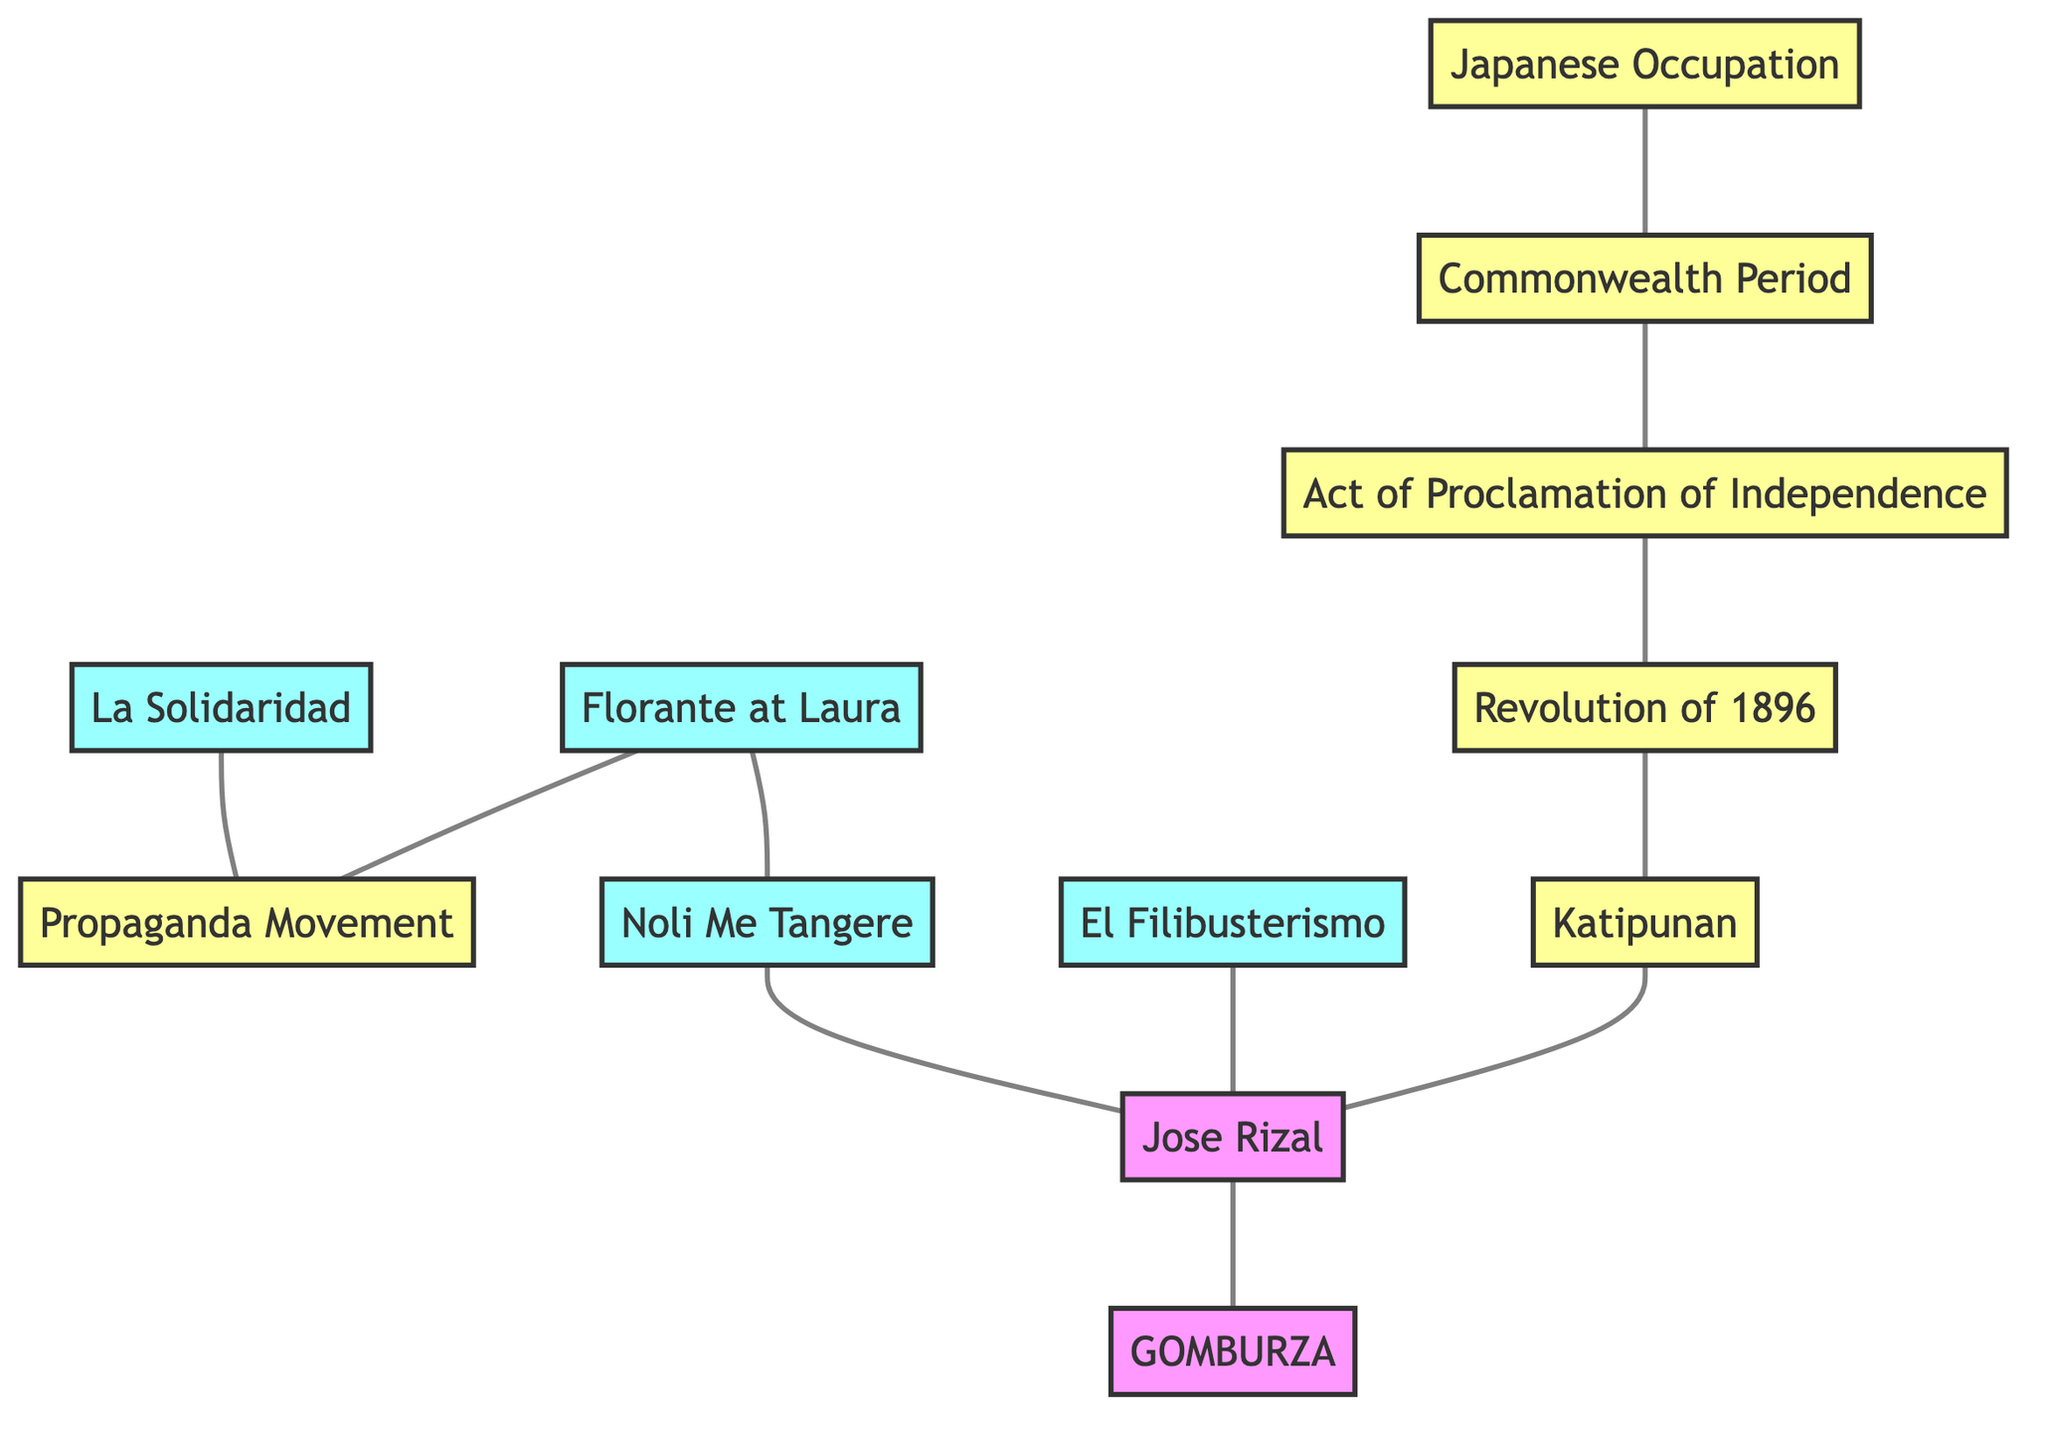What is the primary literary work associated with Jose Rizal? Jose Rizal is directly linked to two literary works in the diagram: "Noli Me Tangere" and "El Filibusterismo". The question specifically asks for one, so either of these is correct.
Answer: Noli Me Tangere How many literary publications are represented in the diagram? To find the count, we can identify the nodes classified under literature. These are "La Solidaridad", "Noli Me Tangere", "El Filibusterismo", and "Florante at Laura", totaling four publications.
Answer: 4 Which event is directly connected to the Propaganda Movement? The diagram indicates that "La Solidaridad" is linked to "Propaganda Movement", establishing that the literary work is a part of this movement.
Answer: La Solidaridad What event follows the Revolution of 1896? The "Act of Proclamation of Independence" directly connects to "Revolution of 1896", meaning it follows this event in the historical timeline illustrated in the graph.
Answer: Act of Proclamation of Independence Who are the three key figures connected to Jose Rizal? Jose Rizal is connected to "GOMBURZA", "Noli Me Tangere", and "El Filibusterismo". This connection allows us to identify these figures as key influences of or by Rizal.
Answer: GOMBURZA, Noli Me Tangere, El Filibusterismo What is a common element between "Florante at Laura" and "Propaganda Movement"? The diagram shows a direct connection between "Florante at Laura" and "Propaganda Movement", indicating their relationship in context.
Answer: Propaganda Movement Which historical event is linked to the Japanese Occupation? According to the diagram, the "Commonwealth Period" is connected to the "Japanese Occupation", meaning it is the event that directly precedes it.
Answer: Commonwealth Period What literary work is associated with the Revolution of 1896? The "Katipunan" is the event connected to the "Revolution of 1896", which in the context of the document may refer to literary motivations or expressions associated with this uprising.
Answer: Katipunan Which two literary works share a connection in the diagram? The diagram shows connections between several pairs of works, such as "Florante at Laura" linking with both "Propaganda Movement" and "Noli Me Tangere". This demonstrates shared connections within the literary context.
Answer: Florante at Laura and Noli Me Tangere 